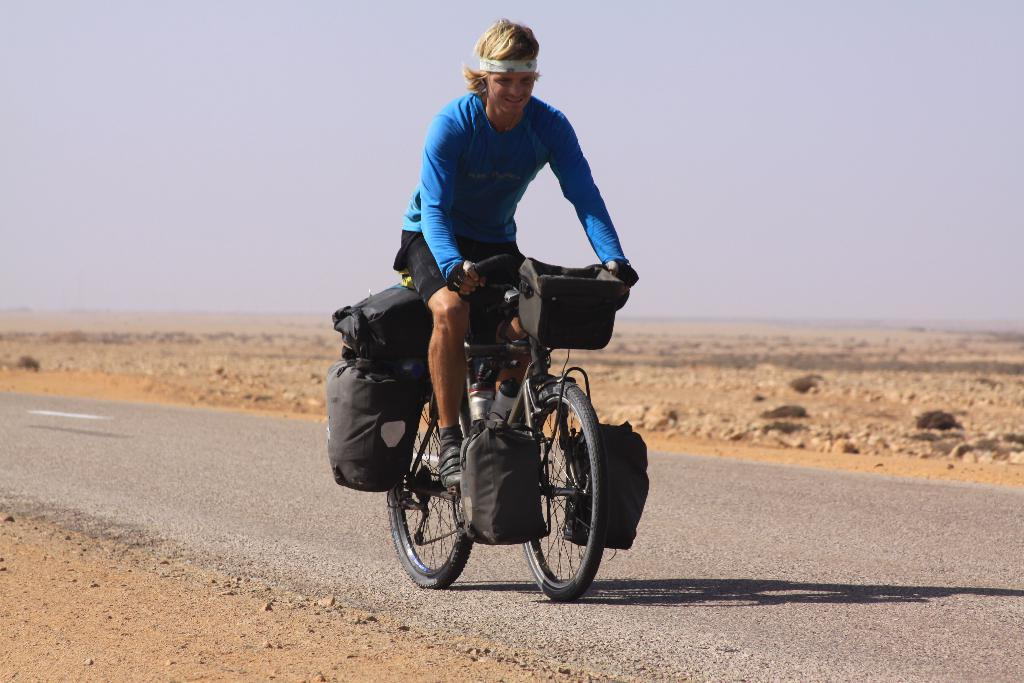Who is the main subject in the image? There is a boy in the image. What is the boy doing in the image? The boy is riding a bicycle. Where is the bicycle located? The bicycle is on a road. What is the boy carrying on the bicycle? The boy is carrying black color bags on the bicycle. What can be inferred about the location of the image? The image appears to be set in a desert area. What time of day is depicted in the image? It is daytime in the image. Where is the stage located in the image? There is no stage present in the image. What is the front of the cellar in the image? There is no cellar present in the image. 